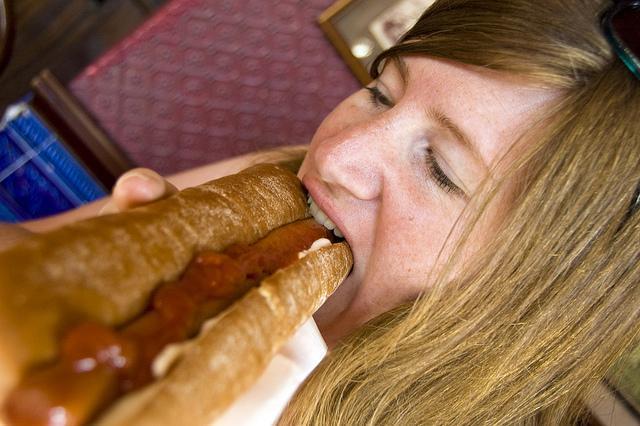Is "The person is facing the hot dog." an appropriate description for the image?
Answer yes or no. Yes. 